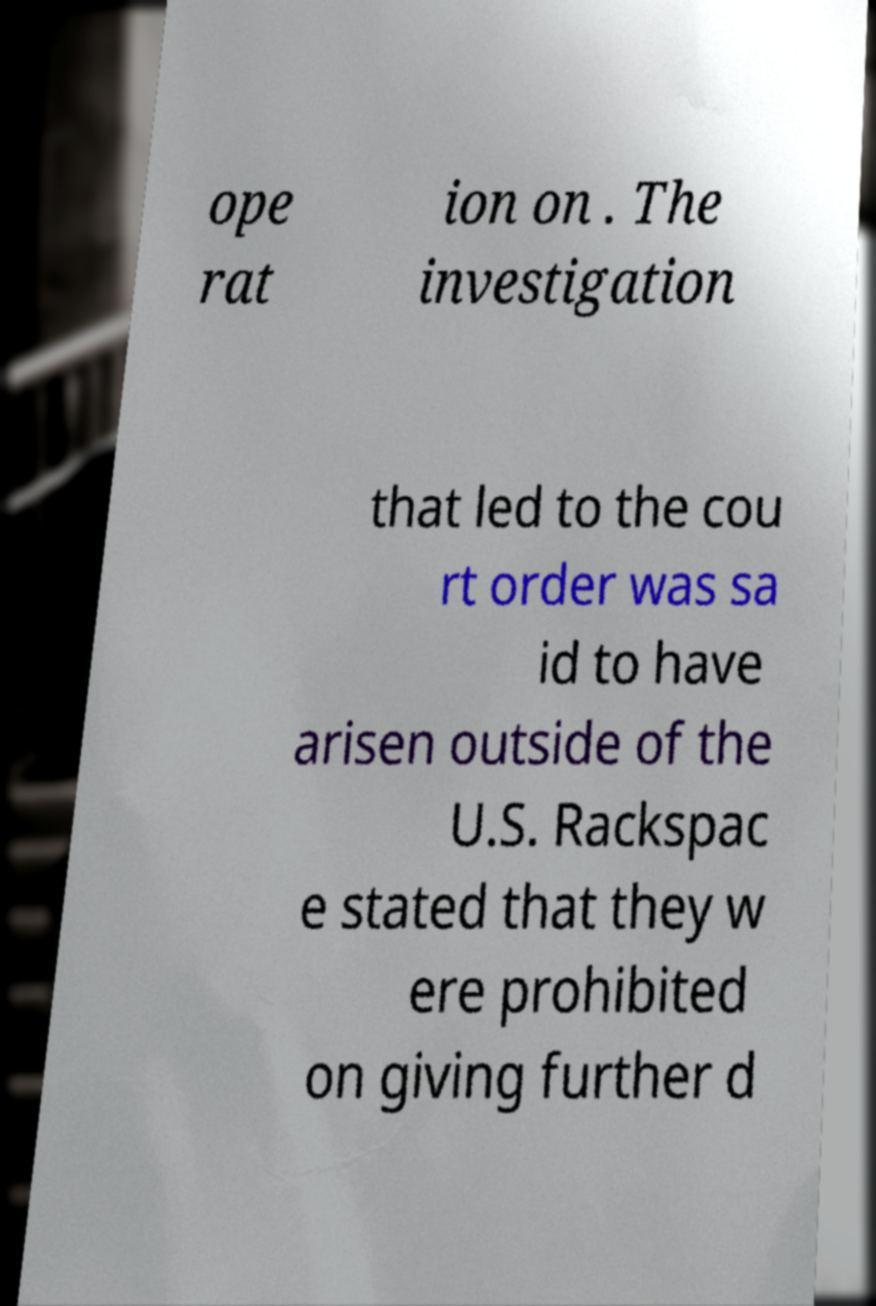There's text embedded in this image that I need extracted. Can you transcribe it verbatim? ope rat ion on . The investigation that led to the cou rt order was sa id to have arisen outside of the U.S. Rackspac e stated that they w ere prohibited on giving further d 